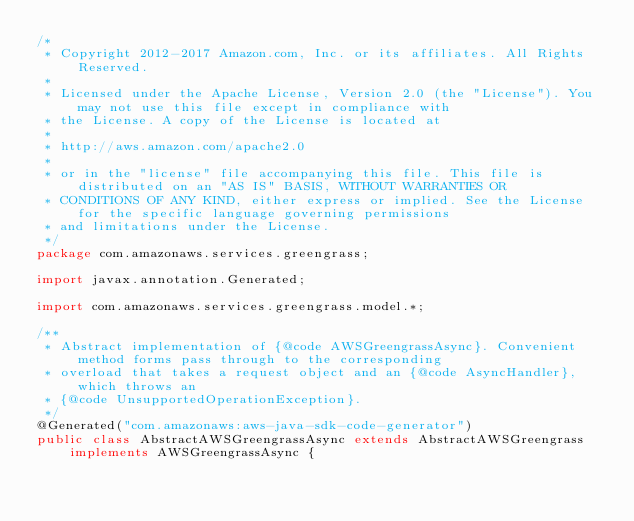<code> <loc_0><loc_0><loc_500><loc_500><_Java_>/*
 * Copyright 2012-2017 Amazon.com, Inc. or its affiliates. All Rights Reserved.
 * 
 * Licensed under the Apache License, Version 2.0 (the "License"). You may not use this file except in compliance with
 * the License. A copy of the License is located at
 * 
 * http://aws.amazon.com/apache2.0
 * 
 * or in the "license" file accompanying this file. This file is distributed on an "AS IS" BASIS, WITHOUT WARRANTIES OR
 * CONDITIONS OF ANY KIND, either express or implied. See the License for the specific language governing permissions
 * and limitations under the License.
 */
package com.amazonaws.services.greengrass;

import javax.annotation.Generated;

import com.amazonaws.services.greengrass.model.*;

/**
 * Abstract implementation of {@code AWSGreengrassAsync}. Convenient method forms pass through to the corresponding
 * overload that takes a request object and an {@code AsyncHandler}, which throws an
 * {@code UnsupportedOperationException}.
 */
@Generated("com.amazonaws:aws-java-sdk-code-generator")
public class AbstractAWSGreengrassAsync extends AbstractAWSGreengrass implements AWSGreengrassAsync {
</code> 